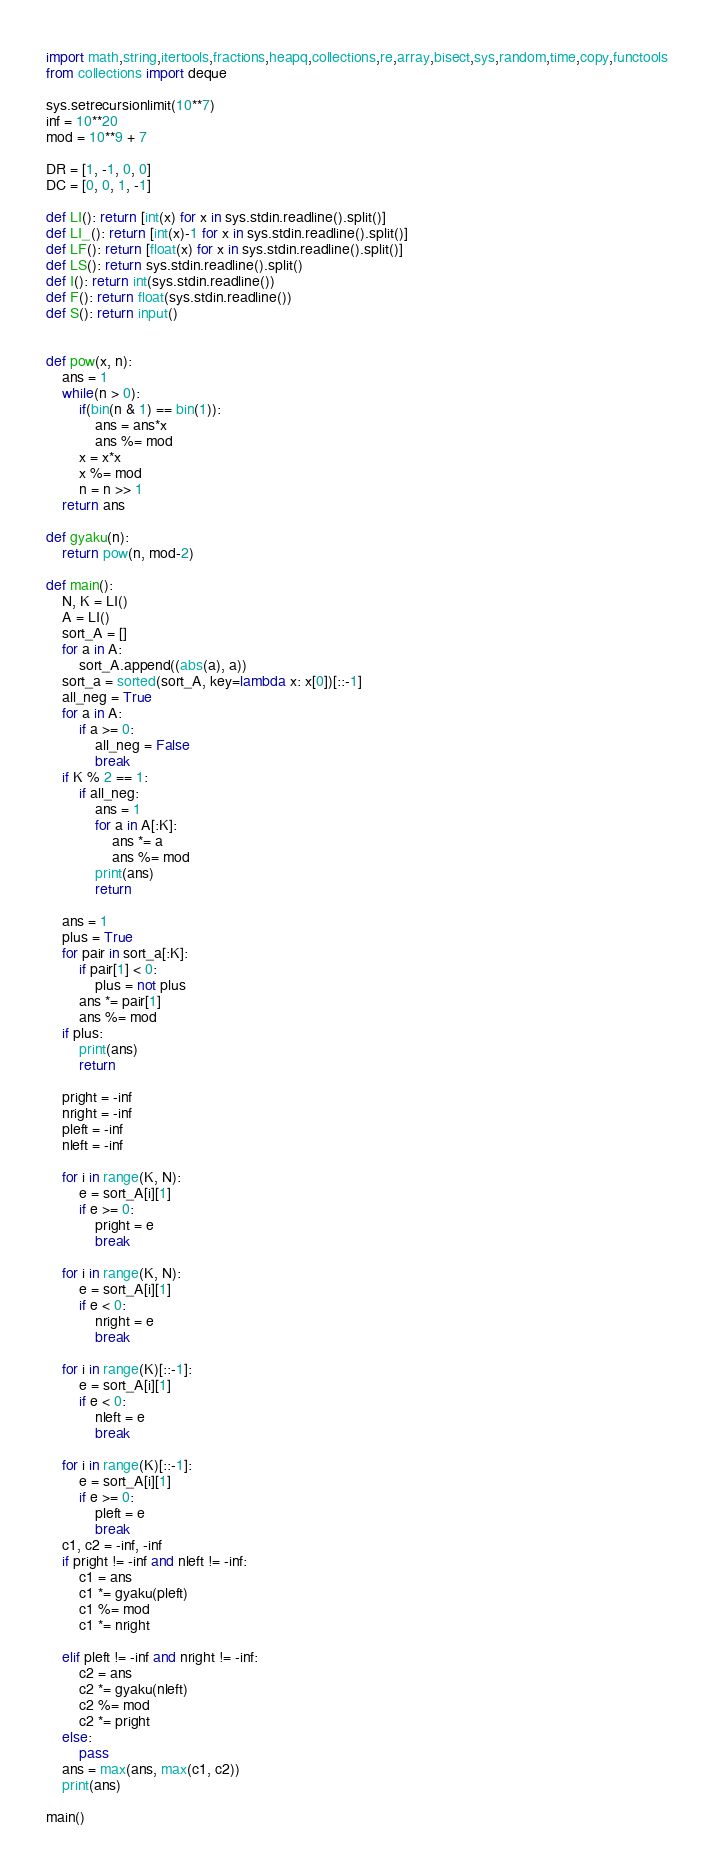<code> <loc_0><loc_0><loc_500><loc_500><_Python_>import math,string,itertools,fractions,heapq,collections,re,array,bisect,sys,random,time,copy,functools
from collections import deque

sys.setrecursionlimit(10**7)
inf = 10**20
mod = 10**9 + 7

DR = [1, -1, 0, 0]
DC = [0, 0, 1, -1]

def LI(): return [int(x) for x in sys.stdin.readline().split()]
def LI_(): return [int(x)-1 for x in sys.stdin.readline().split()]
def LF(): return [float(x) for x in sys.stdin.readline().split()]
def LS(): return sys.stdin.readline().split()
def I(): return int(sys.stdin.readline())
def F(): return float(sys.stdin.readline())
def S(): return input()
     

def pow(x, n):
    ans = 1
    while(n > 0):
        if(bin(n & 1) == bin(1)):
            ans = ans*x
            ans %= mod
        x = x*x
        x %= mod
        n = n >> 1
    return ans

def gyaku(n):
    return pow(n, mod-2)

def main():
    N, K = LI()
    A = LI()
    sort_A = []
    for a in A:
        sort_A.append((abs(a), a))
    sort_a = sorted(sort_A, key=lambda x: x[0])[::-1]
    all_neg = True
    for a in A:
        if a >= 0:
            all_neg = False
            break
    if K % 2 == 1:
        if all_neg:
            ans = 1
            for a in A[:K]:
                ans *= a
                ans %= mod
            print(ans)
            return

    ans = 1
    plus = True
    for pair in sort_a[:K]:
        if pair[1] < 0:
            plus = not plus
        ans *= pair[1]
        ans %= mod
    if plus:
        print(ans)
        return

    pright = -inf
    nright = -inf
    pleft = -inf
    nleft = -inf

    for i in range(K, N):
        e = sort_A[i][1]
        if e >= 0:
            pright = e
            break

    for i in range(K, N):
        e = sort_A[i][1]
        if e < 0:
            nright = e
            break

    for i in range(K)[::-1]:
        e = sort_A[i][1]
        if e < 0:
            nleft = e
            break

    for i in range(K)[::-1]:
        e = sort_A[i][1]
        if e >= 0:
            pleft = e
            break
    c1, c2 = -inf, -inf
    if pright != -inf and nleft != -inf:
        c1 = ans
        c1 *= gyaku(pleft)
        c1 %= mod
        c1 *= nright

    elif pleft != -inf and nright != -inf:
        c2 = ans
        c2 *= gyaku(nleft)
        c2 %= mod
        c2 *= pright
    else:
        pass
    ans = max(ans, max(c1, c2))
    print(ans)

main()

</code> 